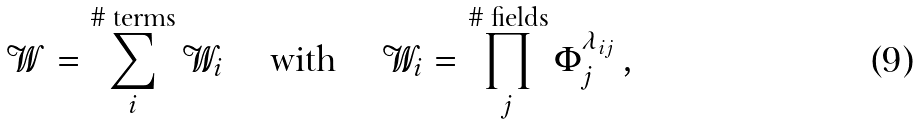<formula> <loc_0><loc_0><loc_500><loc_500>\mathcal { W } = \sum _ { i } ^ { \text {\# terms} } \mathcal { W } _ { i } \quad \text { with } \quad \mathcal { W } _ { i } = \prod _ { j } ^ { \text {\# fields} } \Phi _ { j } ^ { \lambda _ { i j } } \, ,</formula> 